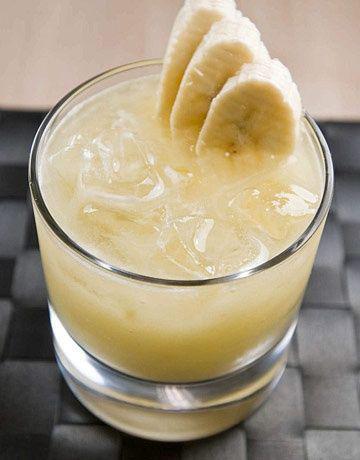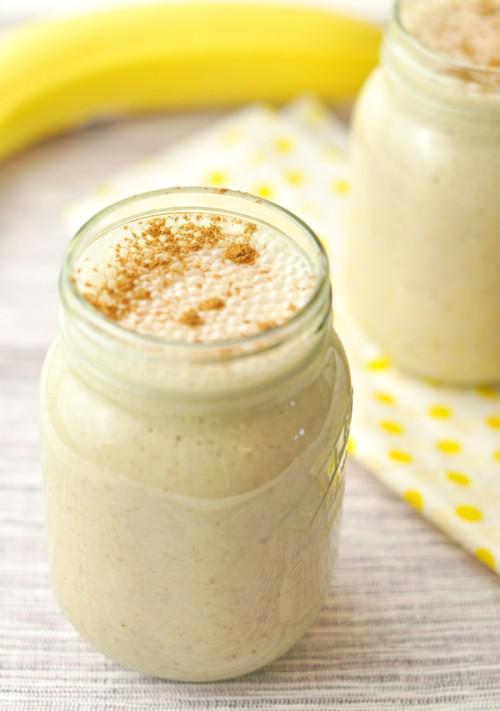The first image is the image on the left, the second image is the image on the right. Analyze the images presented: Is the assertion "One of the drinks has a straw in it." valid? Answer yes or no. No. The first image is the image on the left, the second image is the image on the right. For the images displayed, is the sentence "One glass of creamy beverage has a straw standing in it, and at least one glass of creamy beverage has a wedge of fruit on the rim of the glass." factually correct? Answer yes or no. No. 